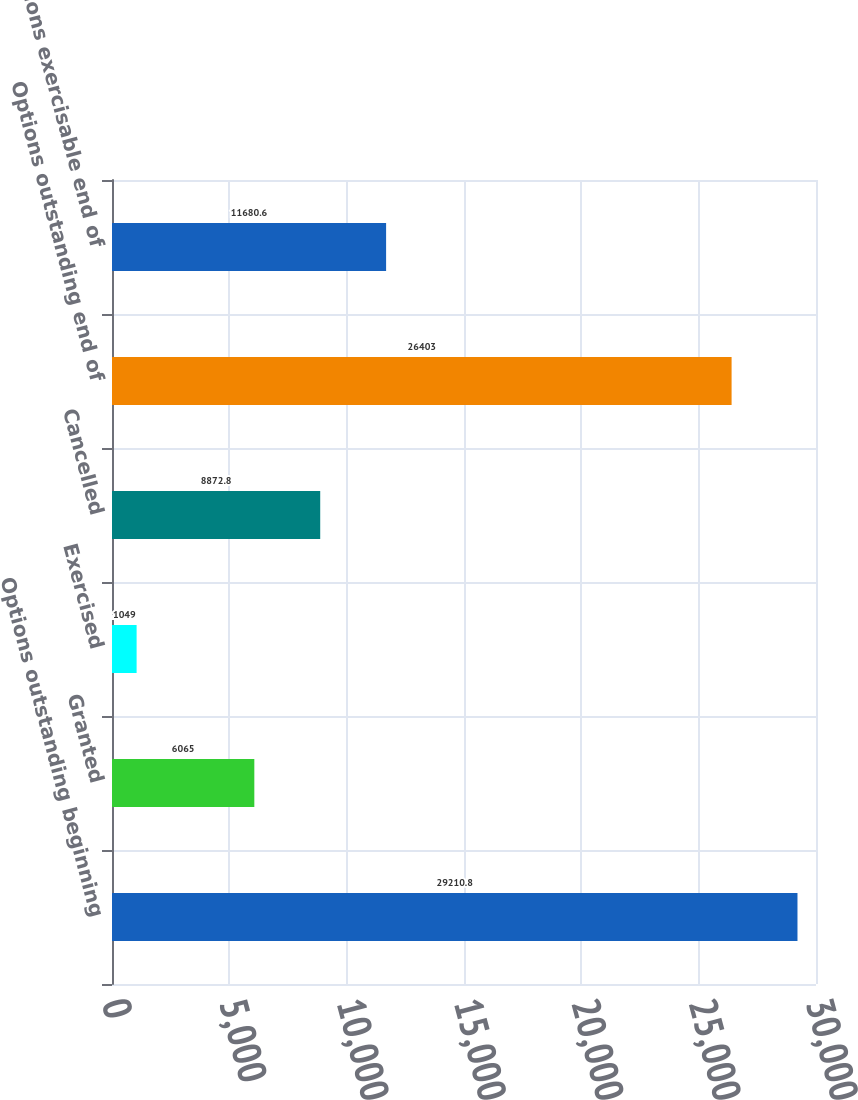<chart> <loc_0><loc_0><loc_500><loc_500><bar_chart><fcel>Options outstanding beginning<fcel>Granted<fcel>Exercised<fcel>Cancelled<fcel>Options outstanding end of<fcel>Options exercisable end of<nl><fcel>29210.8<fcel>6065<fcel>1049<fcel>8872.8<fcel>26403<fcel>11680.6<nl></chart> 